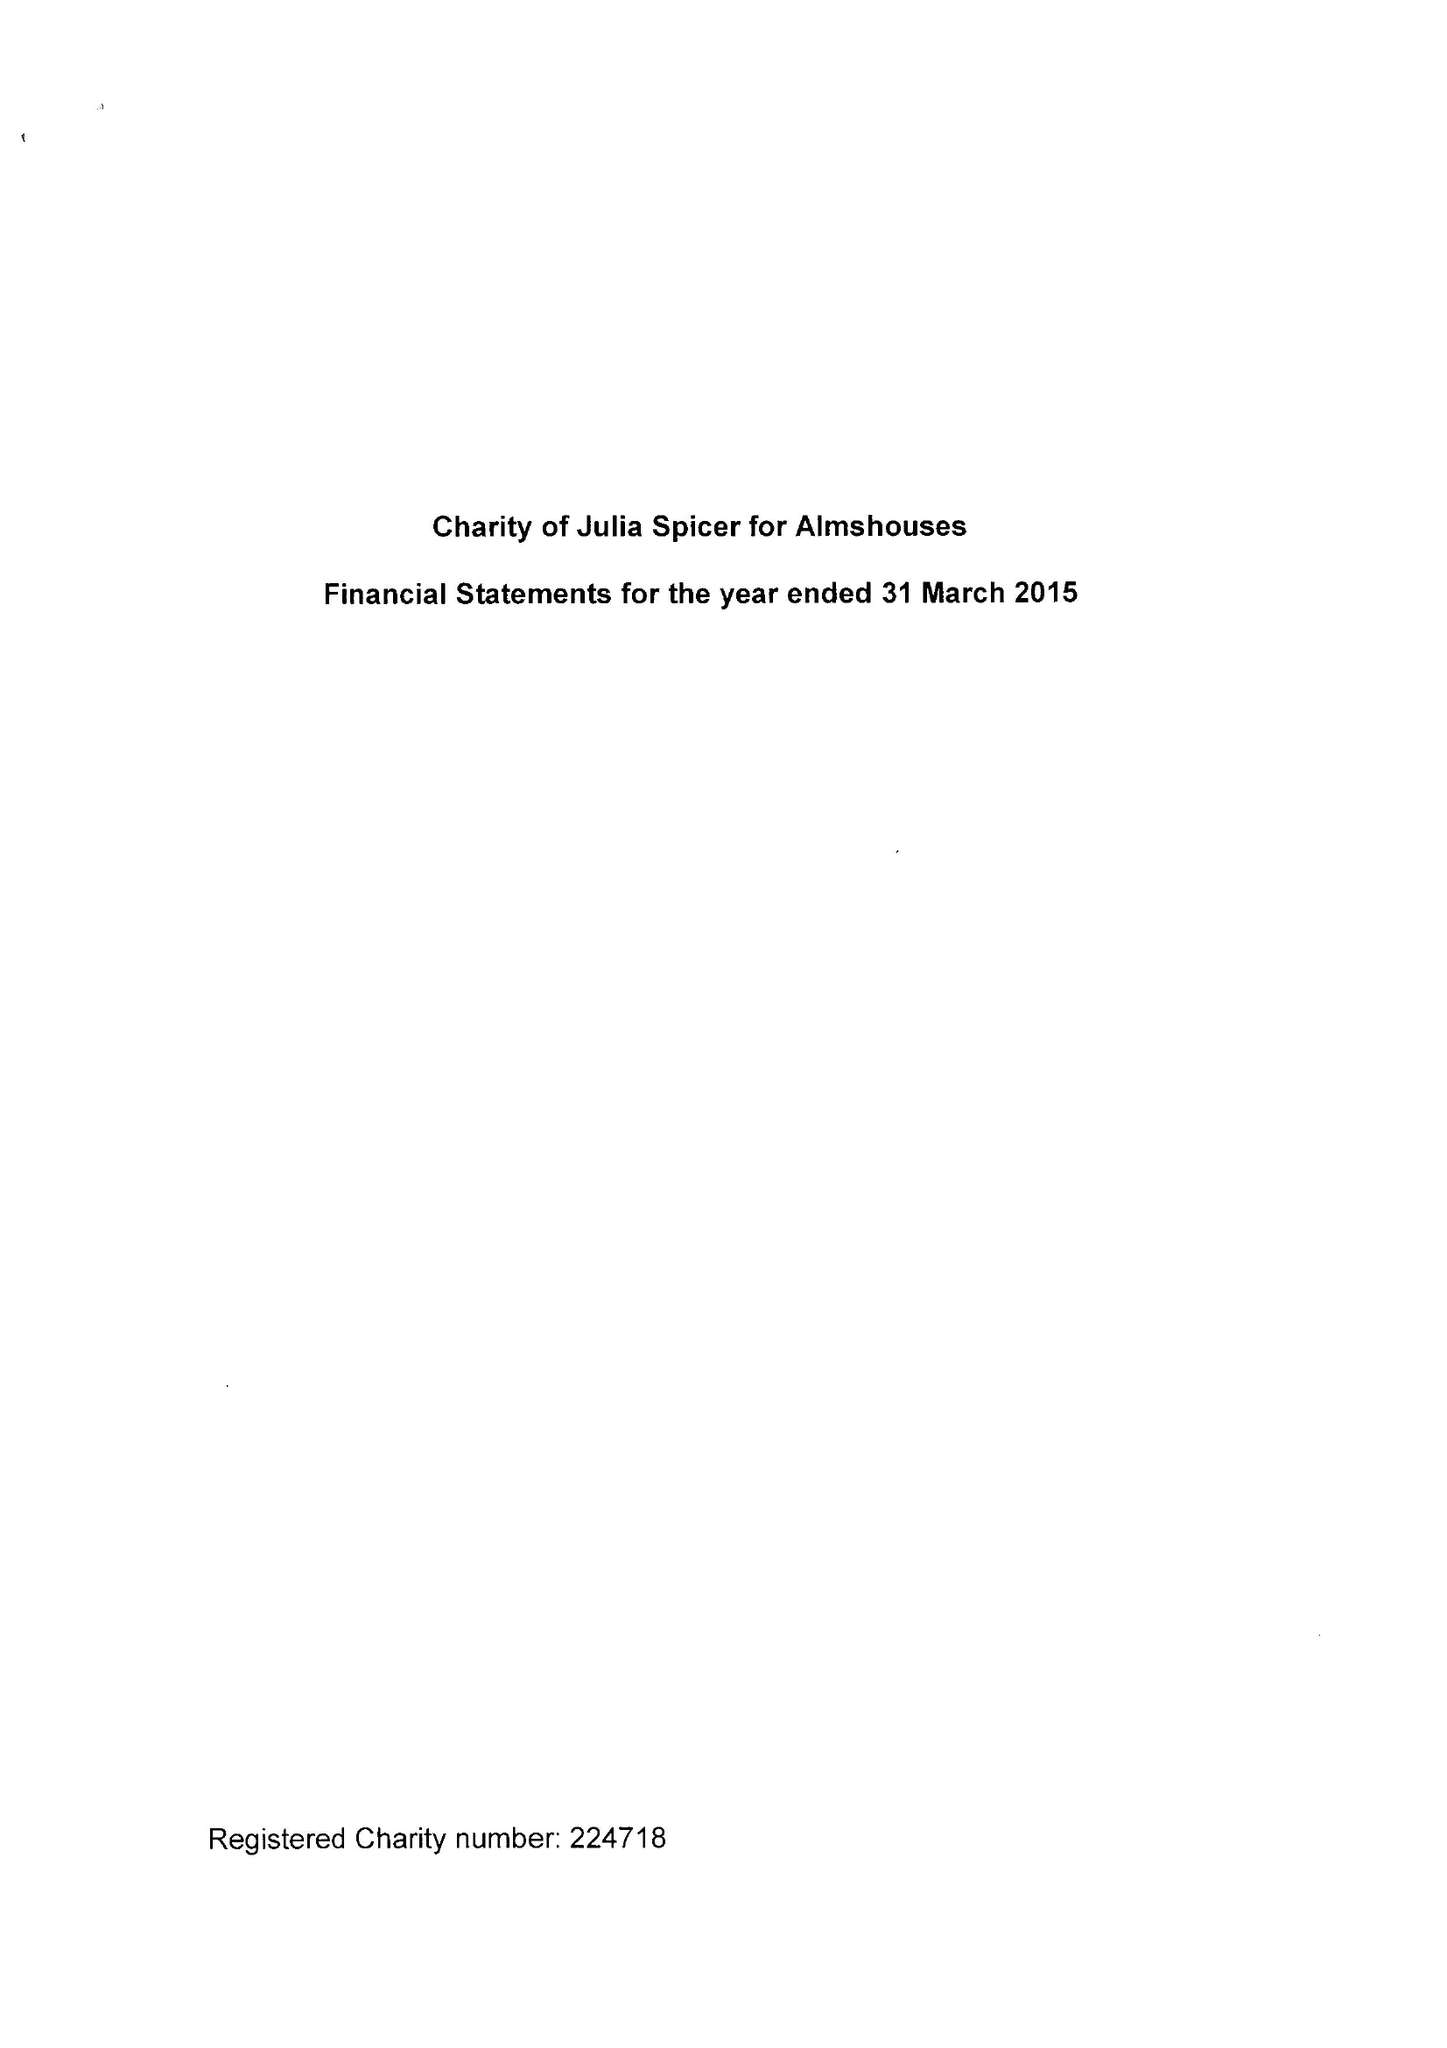What is the value for the income_annually_in_british_pounds?
Answer the question using a single word or phrase. 65453.00 